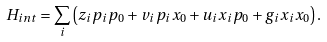<formula> <loc_0><loc_0><loc_500><loc_500>H _ { i n t } = \sum _ { i } \left ( z _ { i } p _ { i } p _ { 0 } + v _ { i } p _ { i } x _ { 0 } + u _ { i } x _ { i } p _ { 0 } + g _ { i } x _ { i } x _ { 0 } \right ) .</formula> 